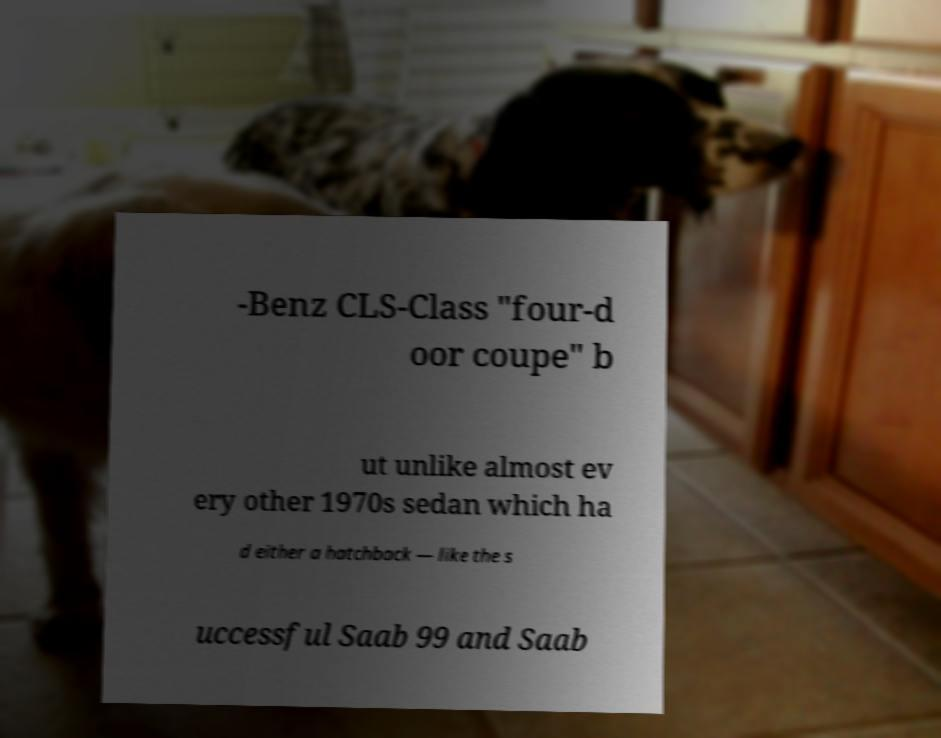Please identify and transcribe the text found in this image. -Benz CLS-Class "four-d oor coupe" b ut unlike almost ev ery other 1970s sedan which ha d either a hatchback — like the s uccessful Saab 99 and Saab 